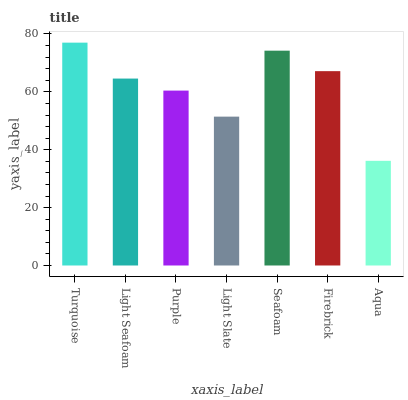Is Light Seafoam the minimum?
Answer yes or no. No. Is Light Seafoam the maximum?
Answer yes or no. No. Is Turquoise greater than Light Seafoam?
Answer yes or no. Yes. Is Light Seafoam less than Turquoise?
Answer yes or no. Yes. Is Light Seafoam greater than Turquoise?
Answer yes or no. No. Is Turquoise less than Light Seafoam?
Answer yes or no. No. Is Light Seafoam the high median?
Answer yes or no. Yes. Is Light Seafoam the low median?
Answer yes or no. Yes. Is Turquoise the high median?
Answer yes or no. No. Is Seafoam the low median?
Answer yes or no. No. 